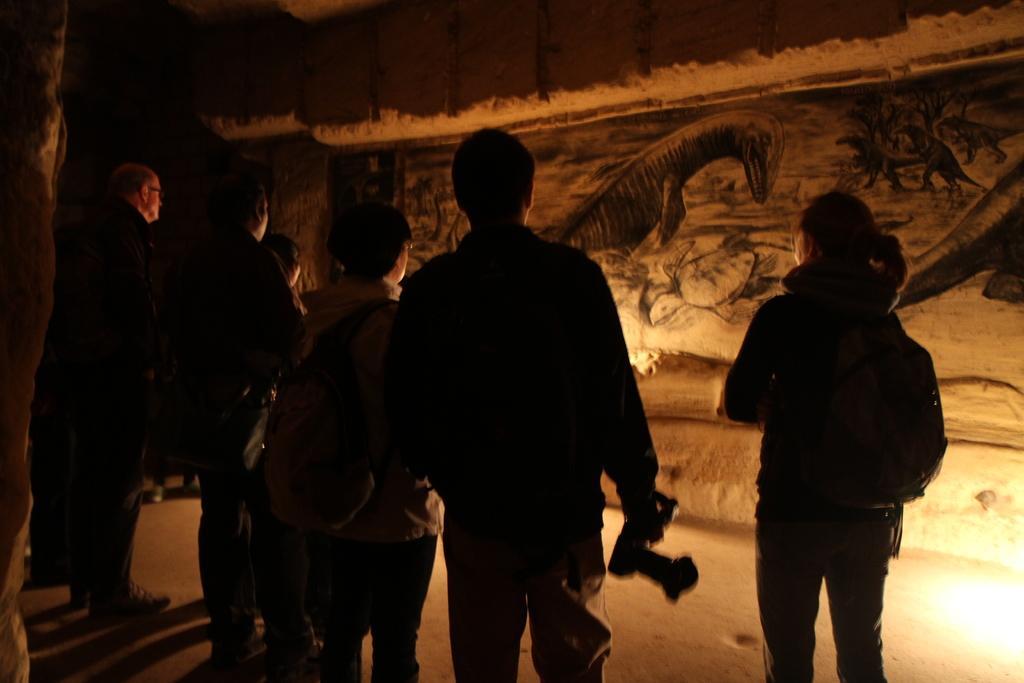Describe this image in one or two sentences. In this image there are group of people who are standing on the floor and looking at the wall. On the wall there is an art. The man in the middle is holding the camera. On the right side bottom there is a light. 